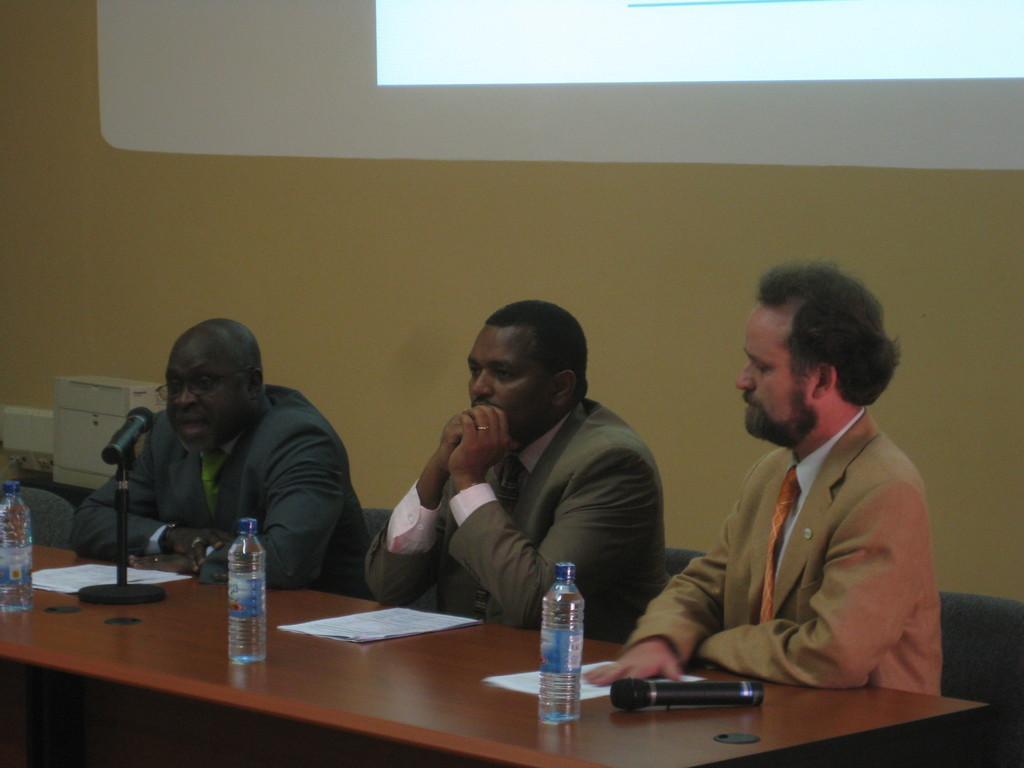Can you describe this image briefly? There are three people who are sitting on a chair. The person on the left side is speaking on a microphone. This is a wooden table where a microphone and a bottle and a paper is kept on it. In the background we can observe there is a screen. 